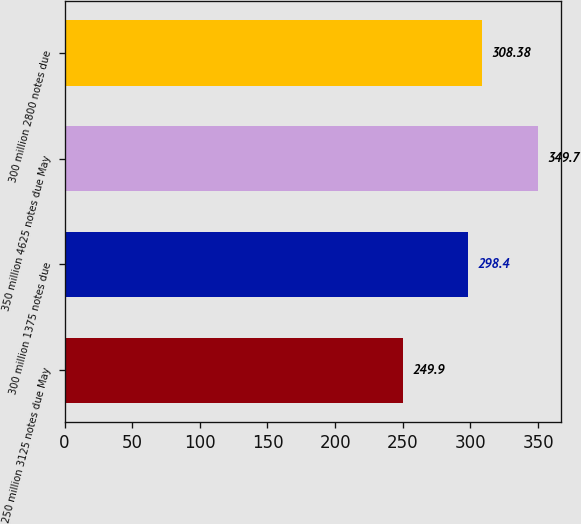<chart> <loc_0><loc_0><loc_500><loc_500><bar_chart><fcel>250 million 3125 notes due May<fcel>300 million 1375 notes due<fcel>350 million 4625 notes due May<fcel>300 million 2800 notes due<nl><fcel>249.9<fcel>298.4<fcel>349.7<fcel>308.38<nl></chart> 